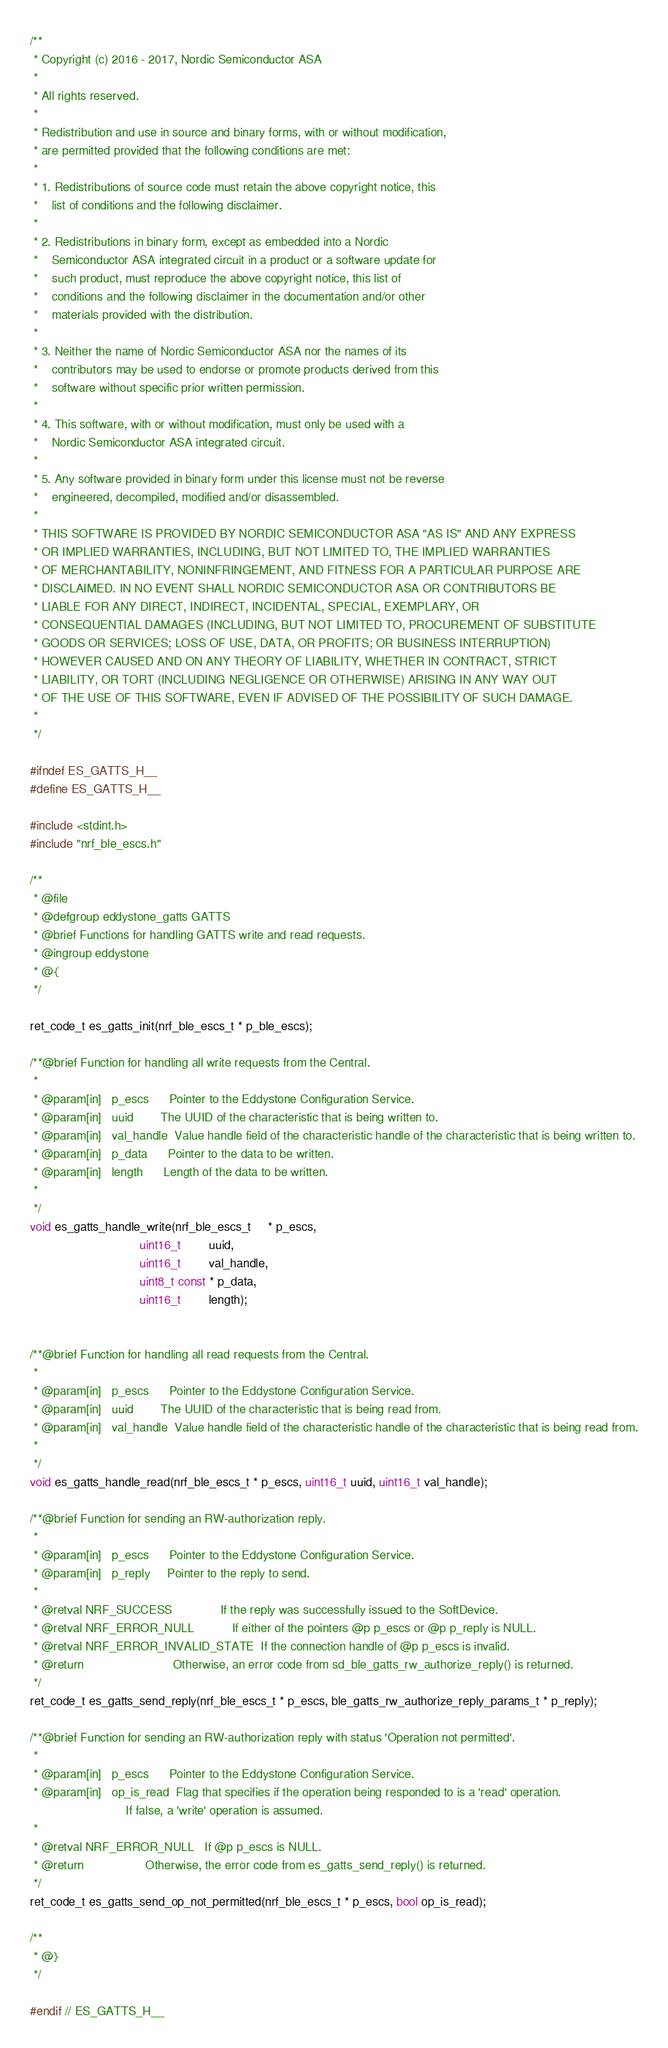<code> <loc_0><loc_0><loc_500><loc_500><_C_>/**
 * Copyright (c) 2016 - 2017, Nordic Semiconductor ASA
 *
 * All rights reserved.
 *
 * Redistribution and use in source and binary forms, with or without modification,
 * are permitted provided that the following conditions are met:
 *
 * 1. Redistributions of source code must retain the above copyright notice, this
 *    list of conditions and the following disclaimer.
 *
 * 2. Redistributions in binary form, except as embedded into a Nordic
 *    Semiconductor ASA integrated circuit in a product or a software update for
 *    such product, must reproduce the above copyright notice, this list of
 *    conditions and the following disclaimer in the documentation and/or other
 *    materials provided with the distribution.
 *
 * 3. Neither the name of Nordic Semiconductor ASA nor the names of its
 *    contributors may be used to endorse or promote products derived from this
 *    software without specific prior written permission.
 *
 * 4. This software, with or without modification, must only be used with a
 *    Nordic Semiconductor ASA integrated circuit.
 *
 * 5. Any software provided in binary form under this license must not be reverse
 *    engineered, decompiled, modified and/or disassembled.
 *
 * THIS SOFTWARE IS PROVIDED BY NORDIC SEMICONDUCTOR ASA "AS IS" AND ANY EXPRESS
 * OR IMPLIED WARRANTIES, INCLUDING, BUT NOT LIMITED TO, THE IMPLIED WARRANTIES
 * OF MERCHANTABILITY, NONINFRINGEMENT, AND FITNESS FOR A PARTICULAR PURPOSE ARE
 * DISCLAIMED. IN NO EVENT SHALL NORDIC SEMICONDUCTOR ASA OR CONTRIBUTORS BE
 * LIABLE FOR ANY DIRECT, INDIRECT, INCIDENTAL, SPECIAL, EXEMPLARY, OR
 * CONSEQUENTIAL DAMAGES (INCLUDING, BUT NOT LIMITED TO, PROCUREMENT OF SUBSTITUTE
 * GOODS OR SERVICES; LOSS OF USE, DATA, OR PROFITS; OR BUSINESS INTERRUPTION)
 * HOWEVER CAUSED AND ON ANY THEORY OF LIABILITY, WHETHER IN CONTRACT, STRICT
 * LIABILITY, OR TORT (INCLUDING NEGLIGENCE OR OTHERWISE) ARISING IN ANY WAY OUT
 * OF THE USE OF THIS SOFTWARE, EVEN IF ADVISED OF THE POSSIBILITY OF SUCH DAMAGE.
 *
 */

#ifndef ES_GATTS_H__
#define ES_GATTS_H__

#include <stdint.h>
#include "nrf_ble_escs.h"

/**
 * @file
 * @defgroup eddystone_gatts GATTS
 * @brief Functions for handling GATTS write and read requests.
 * @ingroup eddystone
 * @{
 */

ret_code_t es_gatts_init(nrf_ble_escs_t * p_ble_escs);

/**@brief Function for handling all write requests from the Central.
 *
 * @param[in]   p_escs      Pointer to the Eddystone Configuration Service.
 * @param[in]   uuid        The UUID of the characteristic that is being written to.
 * @param[in]   val_handle  Value handle field of the characteristic handle of the characteristic that is being written to.
 * @param[in]   p_data      Pointer to the data to be written.
 * @param[in]   length      Length of the data to be written.
 *
 */
void es_gatts_handle_write(nrf_ble_escs_t     * p_escs,
                                uint16_t        uuid,
                                uint16_t        val_handle,
                                uint8_t const * p_data,
                                uint16_t        length);


/**@brief Function for handling all read requests from the Central.
 *
 * @param[in]   p_escs      Pointer to the Eddystone Configuration Service.
 * @param[in]   uuid        The UUID of the characteristic that is being read from.
 * @param[in]   val_handle  Value handle field of the characteristic handle of the characteristic that is being read from.
 *
 */
void es_gatts_handle_read(nrf_ble_escs_t * p_escs, uint16_t uuid, uint16_t val_handle);

/**@brief Function for sending an RW-authorization reply.
 *
 * @param[in]   p_escs      Pointer to the Eddystone Configuration Service.
 * @param[in]   p_reply     Pointer to the reply to send.
 *
 * @retval NRF_SUCCESS              If the reply was successfully issued to the SoftDevice.
 * @retval NRF_ERROR_NULL           If either of the pointers @p p_escs or @p p_reply is NULL.
 * @retval NRF_ERROR_INVALID_STATE  If the connection handle of @p p_escs is invalid.
 * @return                          Otherwise, an error code from sd_ble_gatts_rw_authorize_reply() is returned.
 */
ret_code_t es_gatts_send_reply(nrf_ble_escs_t * p_escs, ble_gatts_rw_authorize_reply_params_t * p_reply);

/**@brief Function for sending an RW-authorization reply with status 'Operation not permitted'.
 *
 * @param[in]   p_escs      Pointer to the Eddystone Configuration Service.
 * @param[in]   op_is_read  Flag that specifies if the operation being responded to is a 'read' operation.
                            If false, a 'write' operation is assumed.
 *
 * @retval NRF_ERROR_NULL   If @p p_escs is NULL.
 * @return                  Otherwise, the error code from es_gatts_send_reply() is returned.
 */
ret_code_t es_gatts_send_op_not_permitted(nrf_ble_escs_t * p_escs, bool op_is_read);

/**
 * @}
 */

#endif // ES_GATTS_H__
</code> 